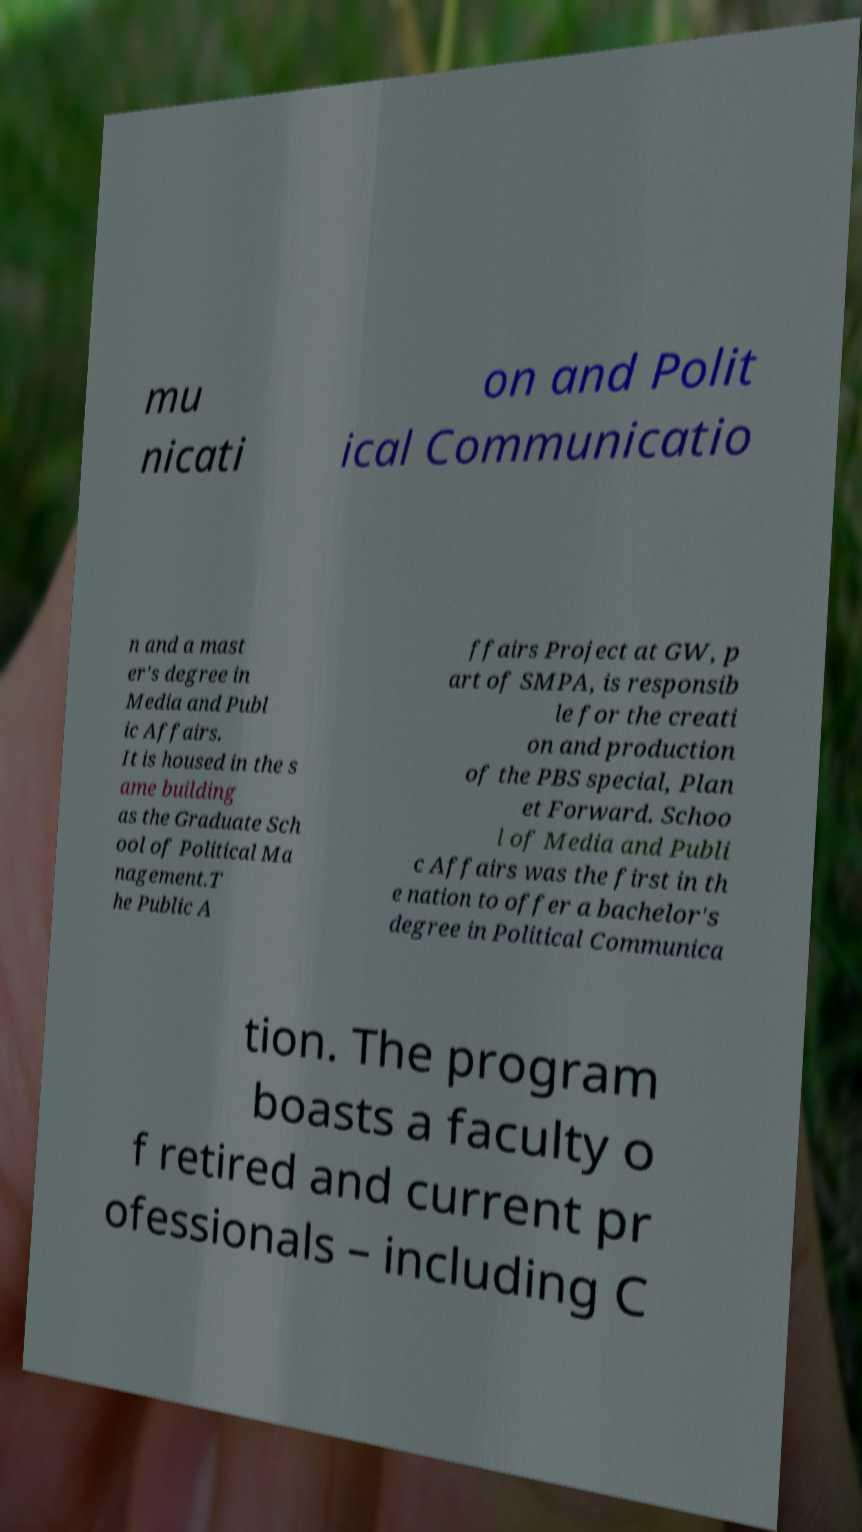For documentation purposes, I need the text within this image transcribed. Could you provide that? mu nicati on and Polit ical Communicatio n and a mast er's degree in Media and Publ ic Affairs. It is housed in the s ame building as the Graduate Sch ool of Political Ma nagement.T he Public A ffairs Project at GW, p art of SMPA, is responsib le for the creati on and production of the PBS special, Plan et Forward. Schoo l of Media and Publi c Affairs was the first in th e nation to offer a bachelor's degree in Political Communica tion. The program boasts a faculty o f retired and current pr ofessionals – including C 